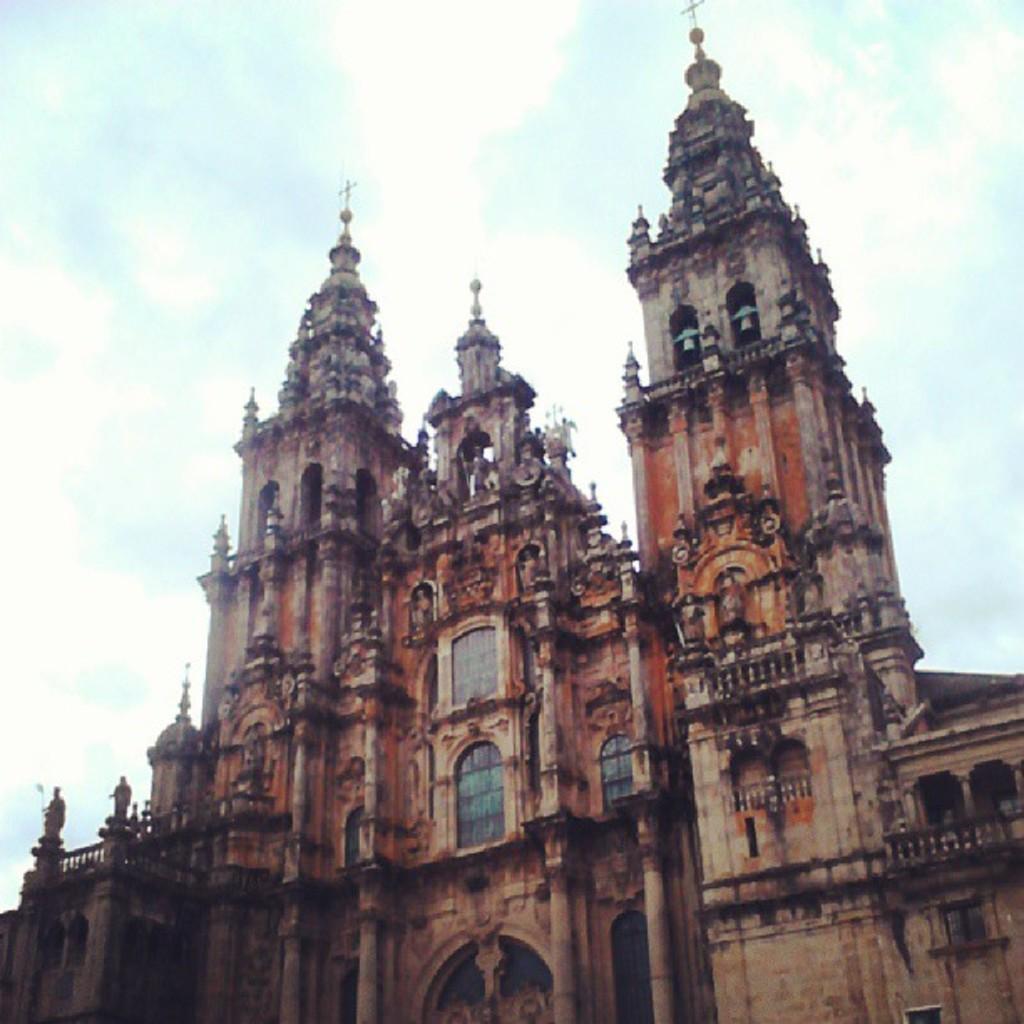Please provide a concise description of this image. In the picture we can see a historical building construction and on it we can see some window and behind it we can see a sky with clouds. 